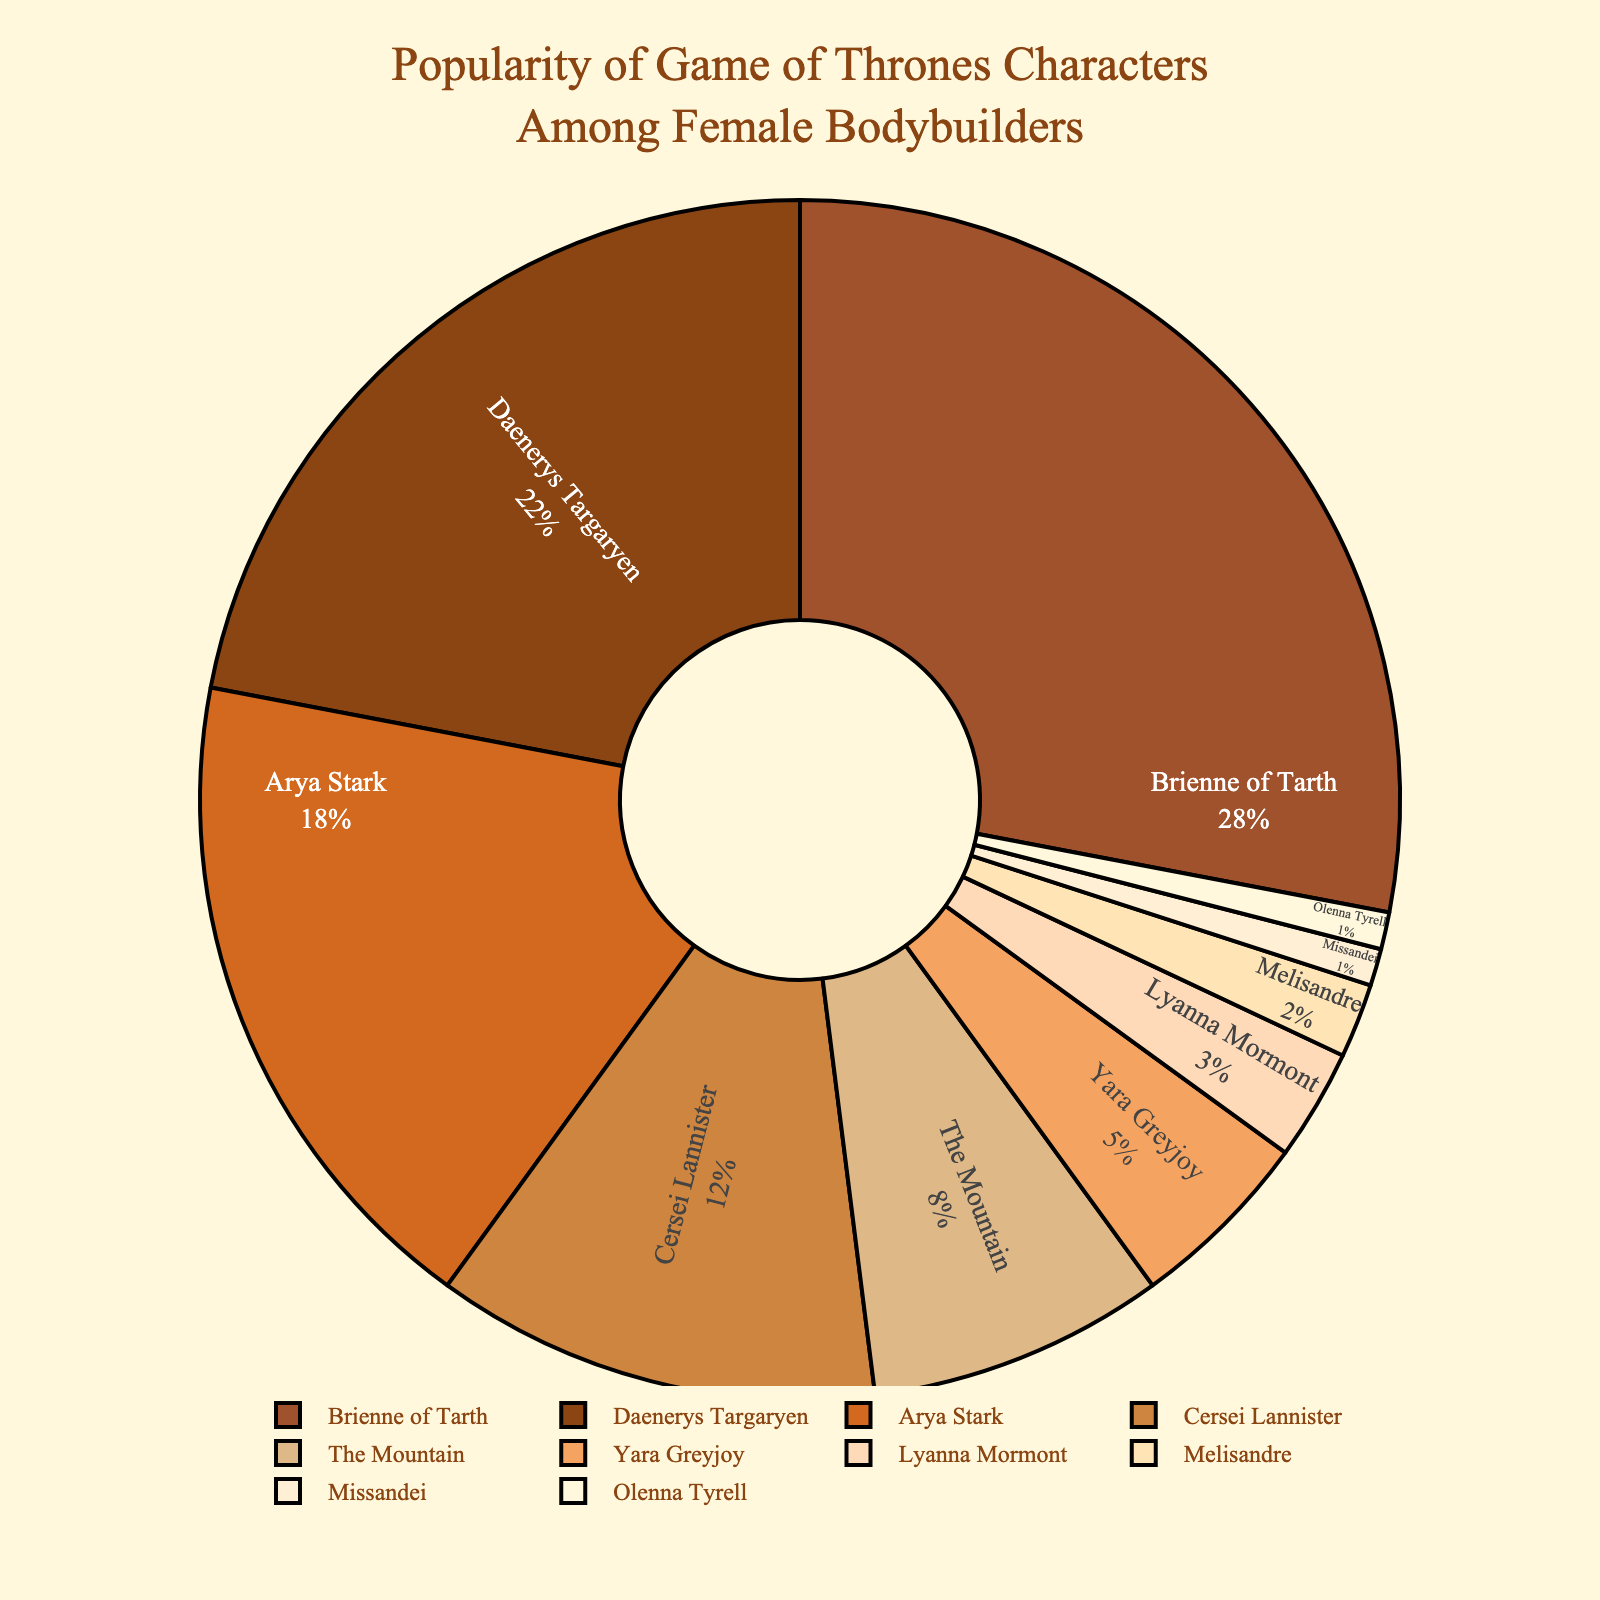Who has the highest popularity percentage among Game of Thrones characters in the female bodybuilding community? To find the character with the highest popularity percentage, look for the largest segment in the pie chart. Brienne of Tarth has the largest segment with 28% popularity.
Answer: Brienne of Tarth What is the combined popularity percentage of Daenerys Targaryen and Arya Stark? To find the combined popularity percentage, sum the percentages of Daenerys Targaryen (22%) and Arya Stark (18%). 22% + 18% = 40%.
Answer: 40% Which character has a smaller popularity percentage, Cersei Lannister or Yara Greyjoy? Compare the segments for Cersei Lannister (12%) and Yara Greyjoy (5%). Yara Greyjoy has a smaller percentage.
Answer: Yara Greyjoy What is the total percentage for the three least popular characters? Sum the percentages of the three least popular characters: Missandei (1%), Olenna Tyrell (1%), and Melisandre (2%). 1% + 1% + 2% = 4%.
Answer: 4% If you combine the popularity percentages of The Mountain and Brienne of Tarth, would it be more or less than half of the total chart? Sum The Mountain (8%) and Brienne of Tarth (28%). 8% + 28% = 36%. Compare this to half of the total chart, which is 50%. 36% is less than 50%.
Answer: Less Who has more popularity, Arya Stark or the sum of Yara Greyjoy and Lyanna Mormont? Compare Arya Stark's percentage (18%) with the sum of Yara Greyjoy (5%) and Lyanna Mormont (3%). 5% + 3% = 8%. 18% is more than 8%.
Answer: Arya Stark What is the difference in popularity between the most popular character and the least popular character? Subtract the popularity percentage of the least popular character (Missandei, 1%) from the most popular character (Brienne of Tarth, 28%). 28% - 1% = 27%.
Answer: 27% Which color section represents Daenerys Targaryen in the pie chart? Look for the segment closest to 22% in size and find its corresponding color. The segment for Daenerys Targaryen is second largest and would be the second color in the custom palette '#8B4513'.
Answer: Brown 